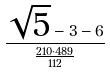Convert formula to latex. <formula><loc_0><loc_0><loc_500><loc_500>\frac { \sqrt { 5 } - 3 - 6 } { \frac { 2 1 0 \cdot 4 8 9 } { 1 1 2 } }</formula> 